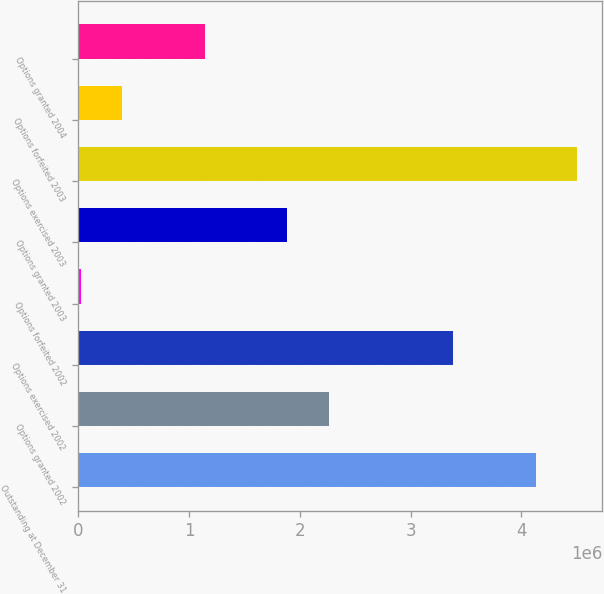Convert chart. <chart><loc_0><loc_0><loc_500><loc_500><bar_chart><fcel>Outstanding at December 31<fcel>Options granted 2002<fcel>Options exercised 2002<fcel>Options forfeited 2002<fcel>Options granted 2003<fcel>Options exercised 2003<fcel>Options forfeited 2003<fcel>Options granted 2004<nl><fcel>4.1301e+06<fcel>2.2615e+06<fcel>3.38266e+06<fcel>19168<fcel>1.88777e+06<fcel>4.50382e+06<fcel>392889<fcel>1.14033e+06<nl></chart> 